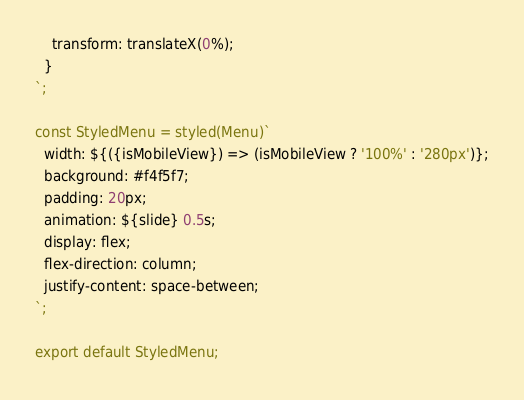<code> <loc_0><loc_0><loc_500><loc_500><_JavaScript_>    transform: translateX(0%);
  }
`;

const StyledMenu = styled(Menu)`
  width: ${({isMobileView}) => (isMobileView ? '100%' : '280px')};
  background: #f4f5f7;
  padding: 20px;
  animation: ${slide} 0.5s;
  display: flex;
  flex-direction: column;
  justify-content: space-between;
`;

export default StyledMenu;
</code> 